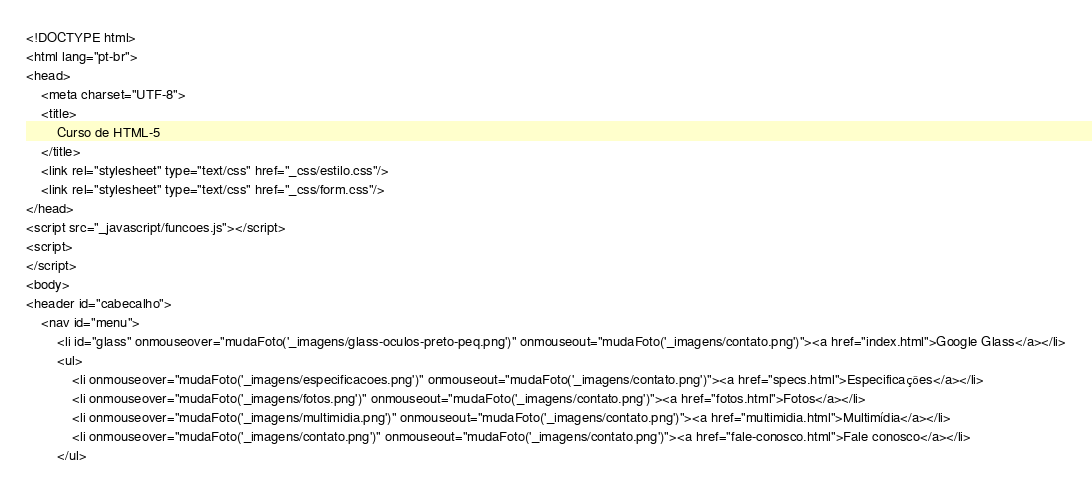Convert code to text. <code><loc_0><loc_0><loc_500><loc_500><_PHP_><!DOCTYPE html>
<html lang="pt-br">
<head>
    <meta charset="UTF-8">
    <title>
        Curso de HTML-5
    </title>
    <link rel="stylesheet" type="text/css" href="_css/estilo.css"/>
    <link rel="stylesheet" type="text/css" href="_css/form.css"/>
</head>
<script src="_javascript/funcoes.js"></script>
<script>
</script>
<body>
<header id="cabecalho">
    <nav id="menu">
        <li id="glass" onmouseover="mudaFoto('_imagens/glass-oculos-preto-peq.png')" onmouseout="mudaFoto('_imagens/contato.png')"><a href="index.html">Google Glass</a></li>
        <ul>
            <li onmouseover="mudaFoto('_imagens/especificacoes.png')" onmouseout="mudaFoto('_imagens/contato.png')"><a href="specs.html">Especificações</a></li>
            <li onmouseover="mudaFoto('_imagens/fotos.png')" onmouseout="mudaFoto('_imagens/contato.png')"><a href="fotos.html">Fotos</a></li>
            <li onmouseover="mudaFoto('_imagens/multimidia.png')" onmouseout="mudaFoto('_imagens/contato.png')"><a href="multimidia.html">Multimídia</a></li>
            <li onmouseover="mudaFoto('_imagens/contato.png')" onmouseout="mudaFoto('_imagens/contato.png')"><a href="fale-conosco.html">Fale conosco</a></li>
        </ul></code> 